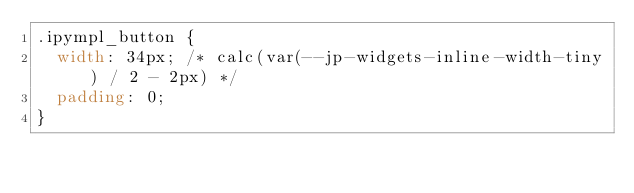<code> <loc_0><loc_0><loc_500><loc_500><_CSS_>.ipympl_button {
  width: 34px; /* calc(var(--jp-widgets-inline-width-tiny) / 2 - 2px) */
  padding: 0;
}
</code> 